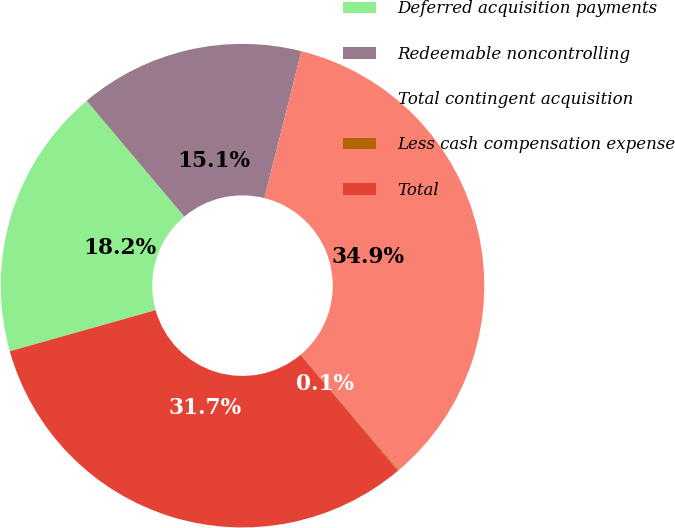Convert chart to OTSL. <chart><loc_0><loc_0><loc_500><loc_500><pie_chart><fcel>Deferred acquisition payments<fcel>Redeemable noncontrolling<fcel>Total contingent acquisition<fcel>Less cash compensation expense<fcel>Total<nl><fcel>18.23%<fcel>15.06%<fcel>34.91%<fcel>0.06%<fcel>31.74%<nl></chart> 